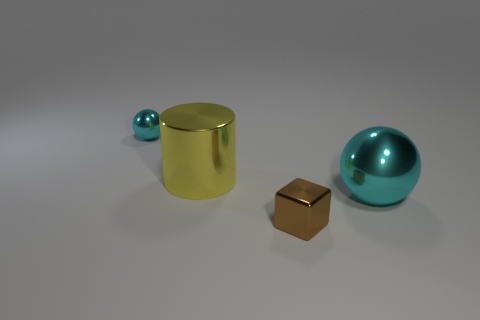What material do the objects in this image seem to be made from? The objects in the image appear to be made from reflective materials typically indicative of metals or metallic finishes. 